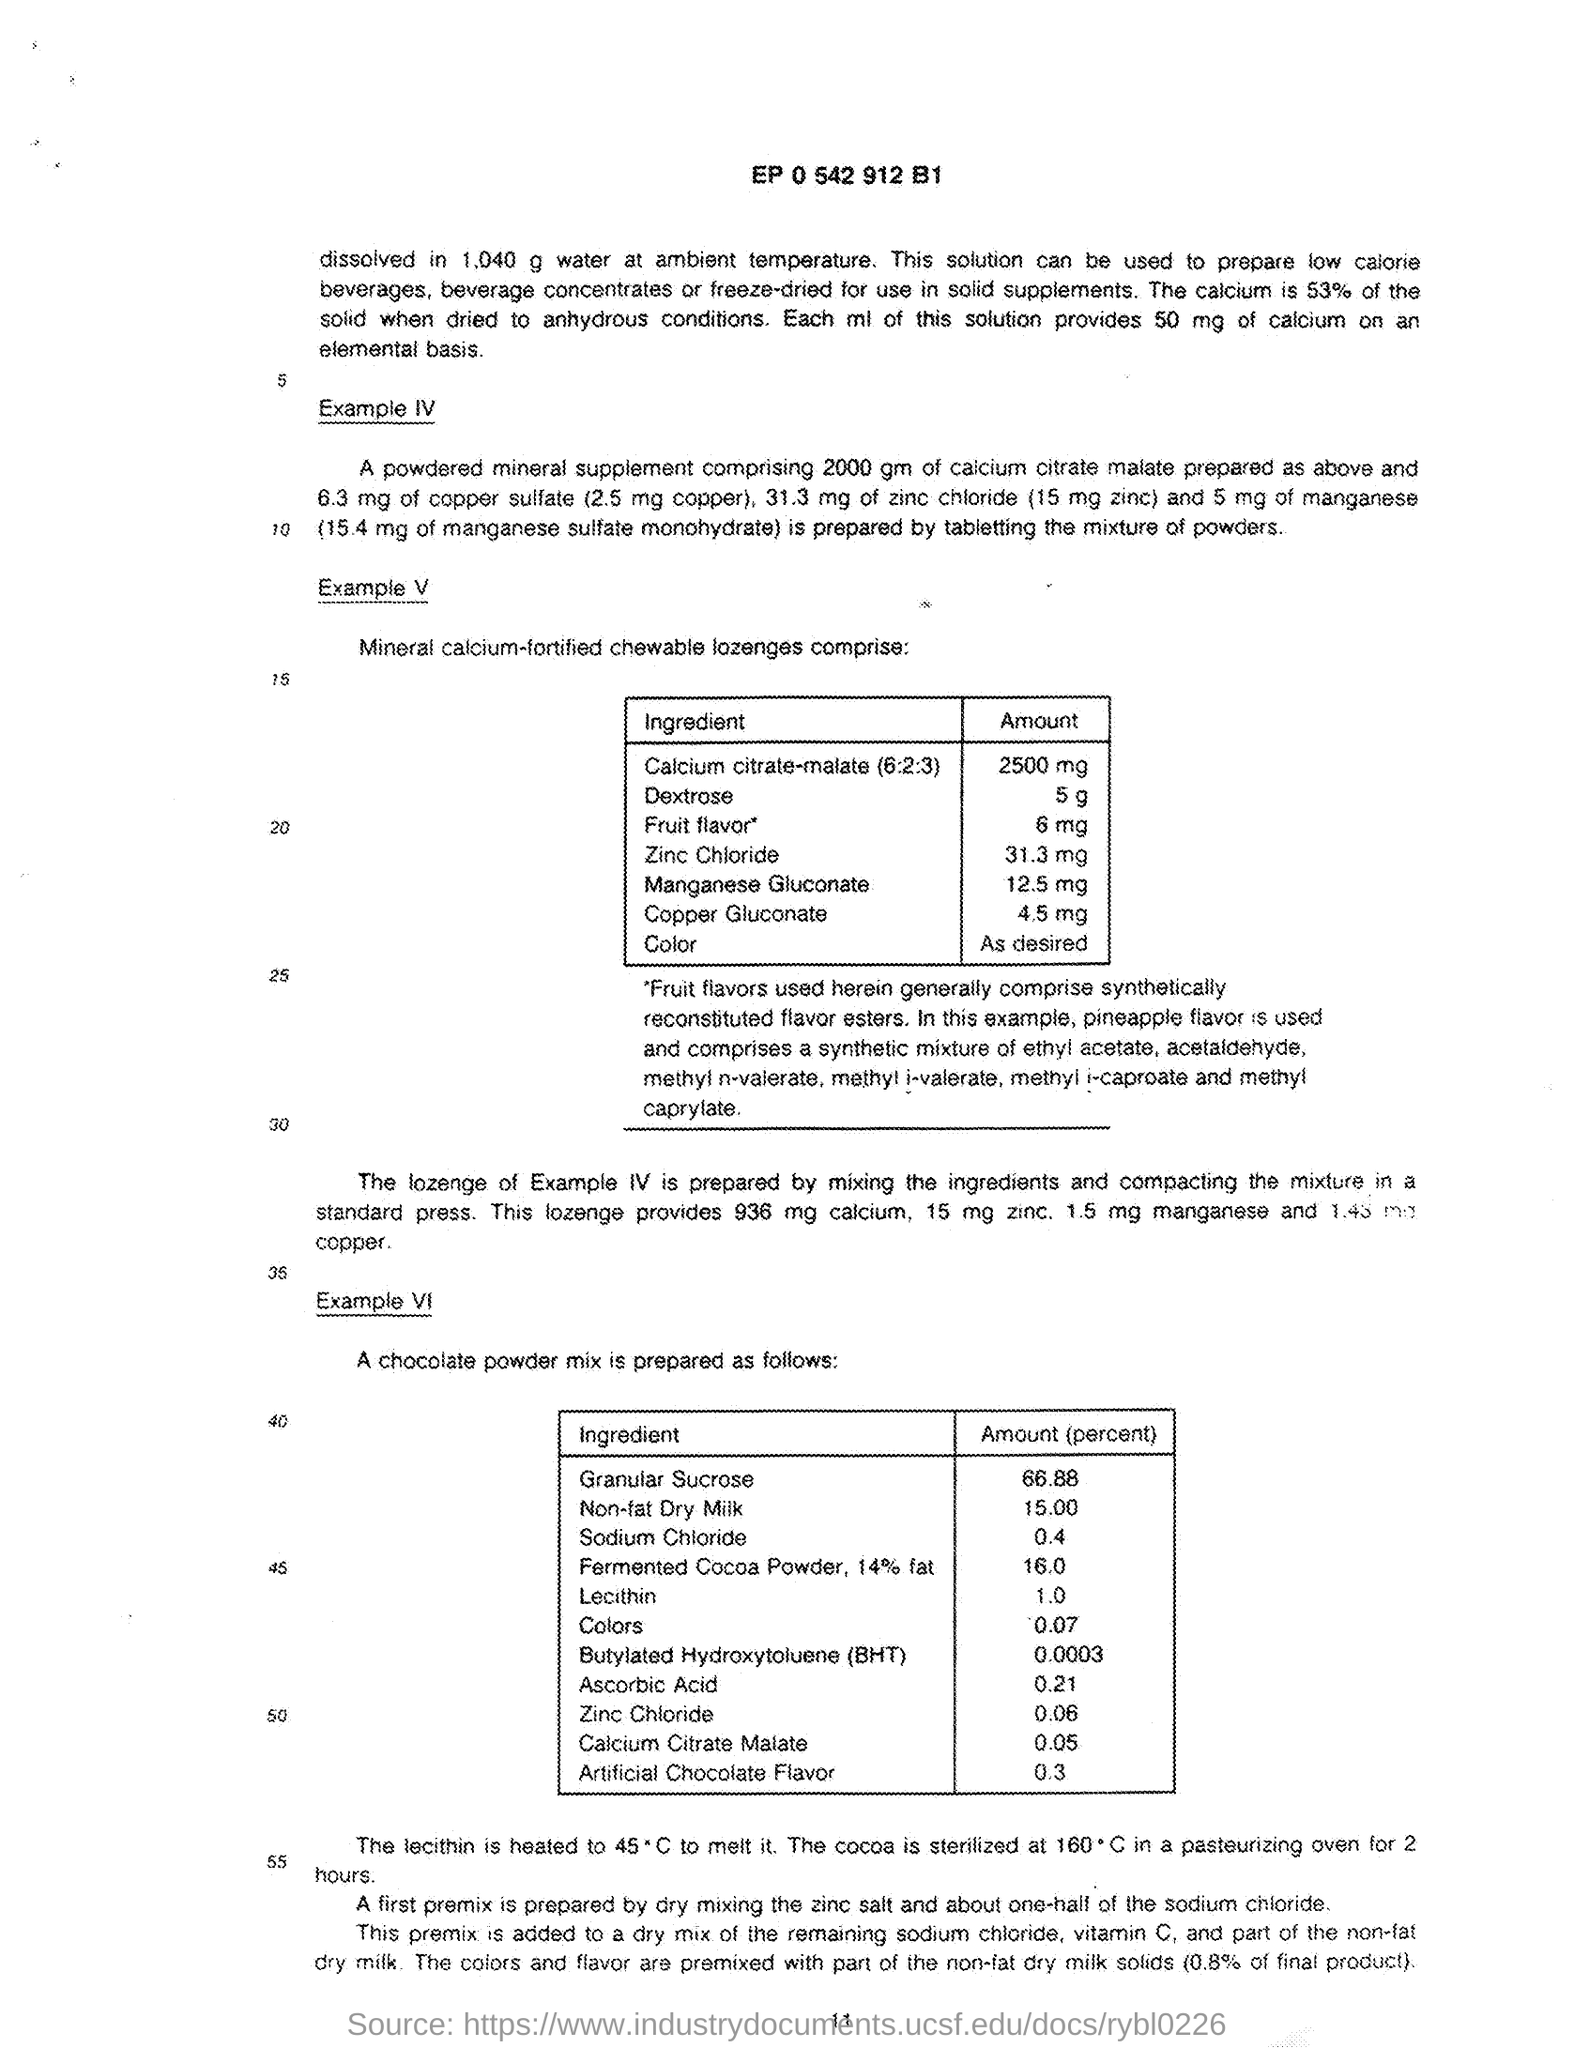What is the amount of Zinc Chloride present in mineral calcium-fortified chewable lozenges as given in Example V?
Your response must be concise. 31.3 mg. Which ingredient with the amount of 12.5mg is present in mineral calcium-fortified chewable lozenges as given in Example V?
Your response must be concise. Manganese Gluconate. Which ingredient with the amount of 2500mg is present in mineral calcium-fortified chewable lozenges as given in Example V?
Your answer should be very brief. Calcium citrate-malate (6:2:3). What is the amount (percent) of Granular Sucrose in a chocolate powder mix as given in Example VI?
Your answer should be compact. 66.88. What is the amount (percent) of Non-fat Dry milk present in a chocolate powder mix as given in Example VI?
Your answer should be very brief. 15.00. 